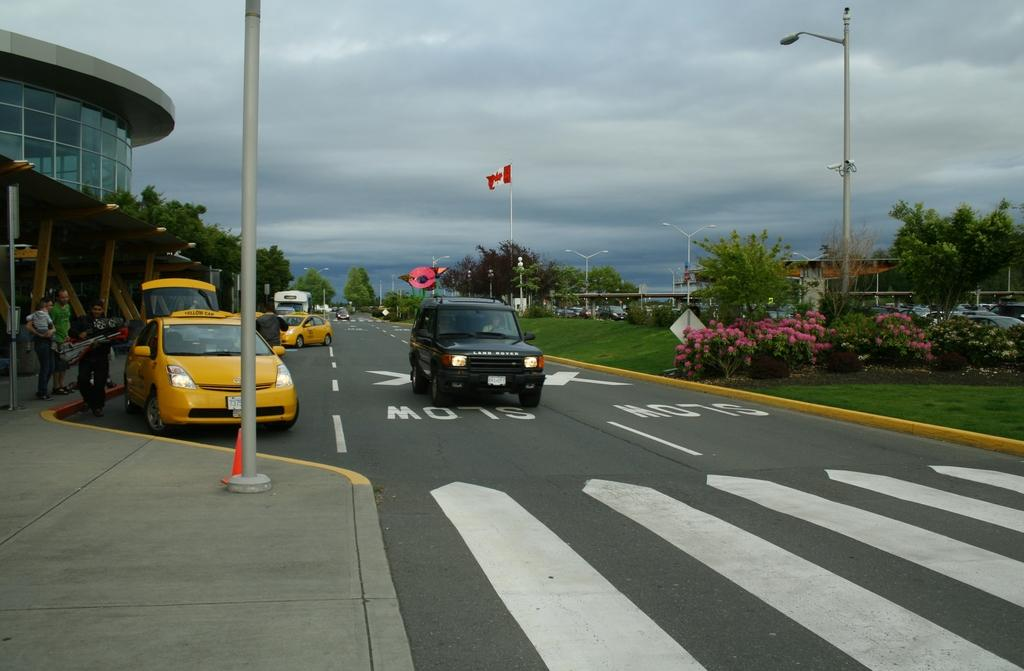<image>
Share a concise interpretation of the image provided. a canadian flag hung on a post above a car parked over the SLOW markings on the road 